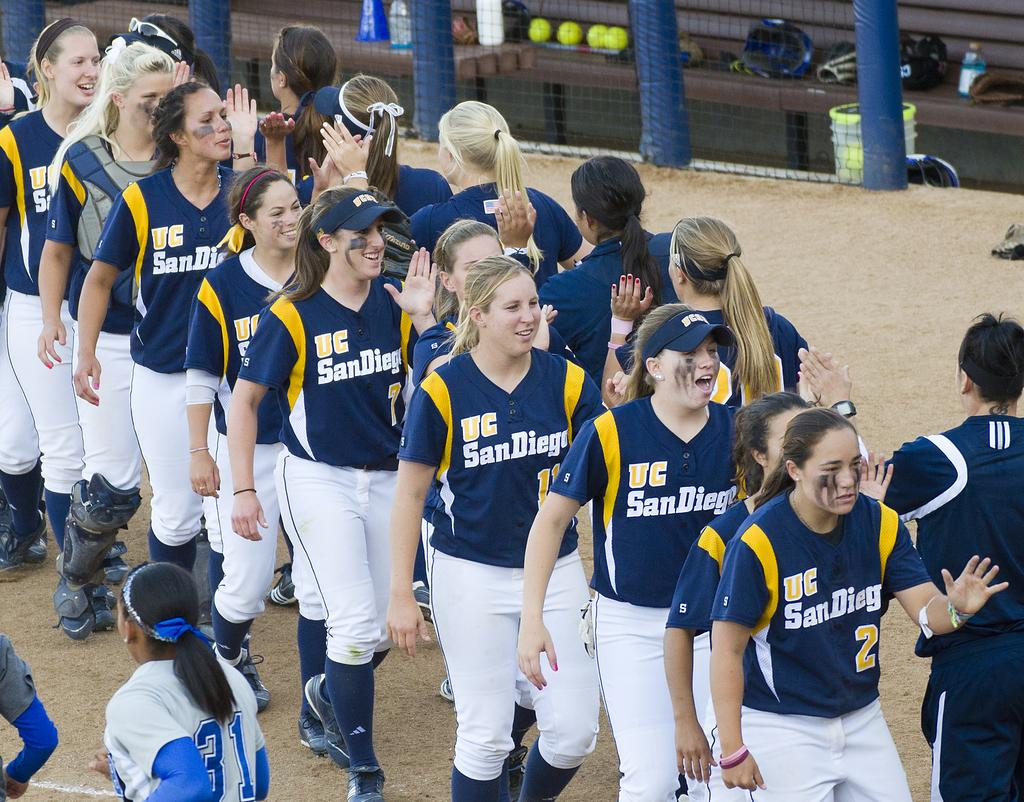<image>
Provide a brief description of the given image. Female baseball players wearing the jersey which says UC San  Diego. 